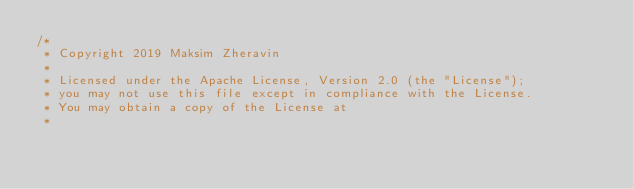<code> <loc_0><loc_0><loc_500><loc_500><_Java_>/*
 * Copyright 2019 Maksim Zheravin
 *
 * Licensed under the Apache License, Version 2.0 (the "License");
 * you may not use this file except in compliance with the License.
 * You may obtain a copy of the License at
 *</code> 